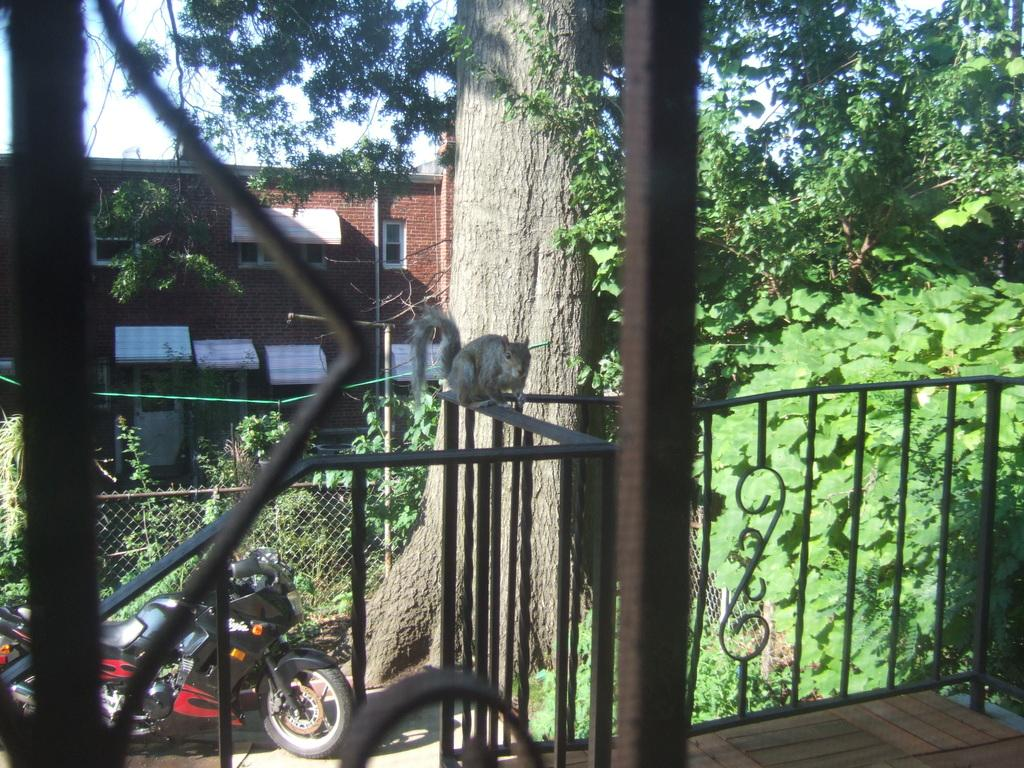What is the main subject of the image? The main subject of the image is a motorcycle. Are there any animals present in the image? Yes, there is a squirrel in the image. What type of barrier can be seen in the image? There is a fence in the image. What type of vegetation is visible in the image? There are trees in the image. What type of structure is present in the image? There is a building in the image. What is visible at the top of the image? The sky is visible at the top of the image. What type of honey is the squirrel collecting from the motorcycle in the image? There is no honey present in the image, and the squirrel is not interacting with the motorcycle. 